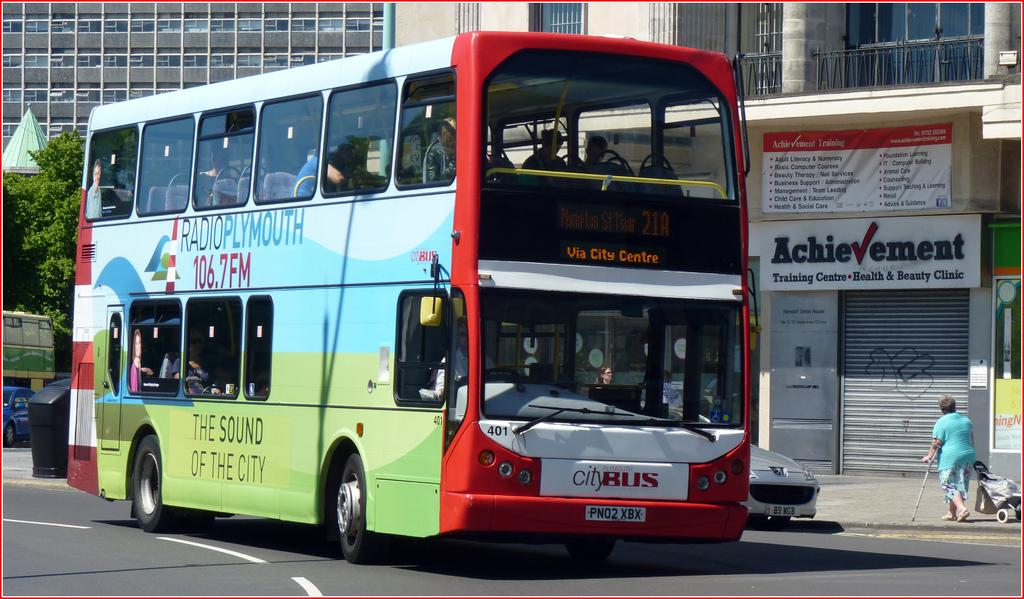Provide a one-sentence caption for the provided image. The double decker bus on the road has a billboard for 106.7 FM on its side. 